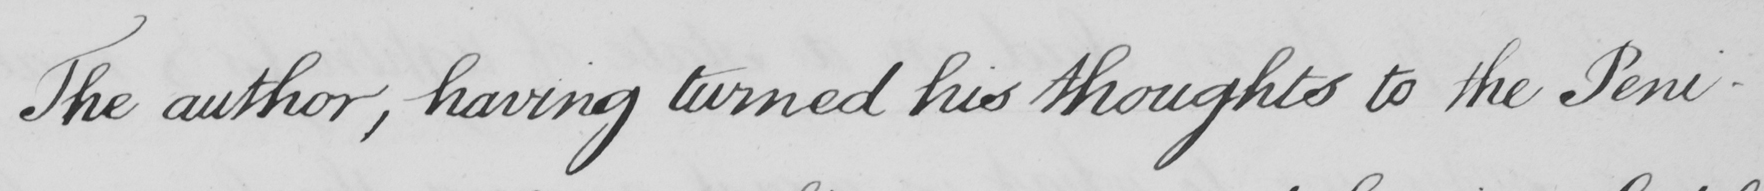What does this handwritten line say? The author , having turned his thoughts to the Peni- 